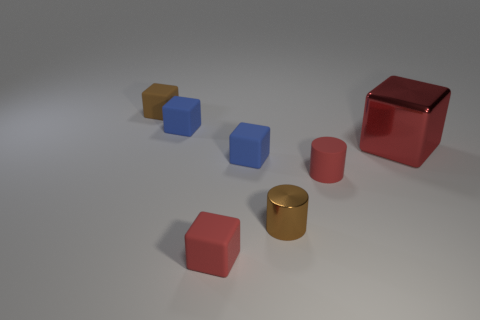Subtract all big red metal blocks. How many blocks are left? 4 Add 2 small brown cylinders. How many objects exist? 9 Subtract all red cubes. How many cubes are left? 3 Subtract all blocks. How many objects are left? 2 Subtract all purple cubes. How many brown cylinders are left? 1 Subtract all tiny red shiny spheres. Subtract all tiny blue matte blocks. How many objects are left? 5 Add 5 tiny brown rubber cubes. How many tiny brown rubber cubes are left? 6 Add 6 red shiny cubes. How many red shiny cubes exist? 7 Subtract 0 green blocks. How many objects are left? 7 Subtract 5 blocks. How many blocks are left? 0 